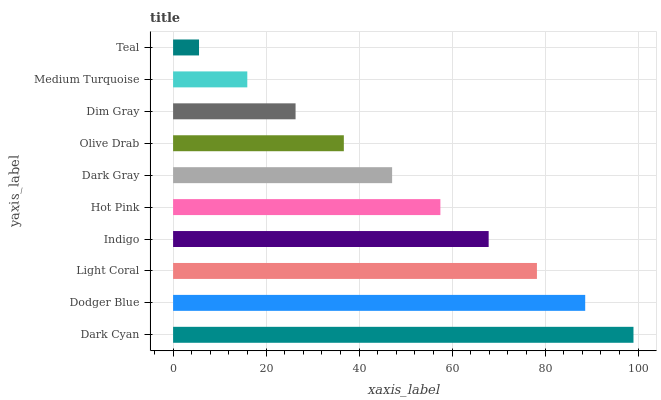Is Teal the minimum?
Answer yes or no. Yes. Is Dark Cyan the maximum?
Answer yes or no. Yes. Is Dodger Blue the minimum?
Answer yes or no. No. Is Dodger Blue the maximum?
Answer yes or no. No. Is Dark Cyan greater than Dodger Blue?
Answer yes or no. Yes. Is Dodger Blue less than Dark Cyan?
Answer yes or no. Yes. Is Dodger Blue greater than Dark Cyan?
Answer yes or no. No. Is Dark Cyan less than Dodger Blue?
Answer yes or no. No. Is Hot Pink the high median?
Answer yes or no. Yes. Is Dark Gray the low median?
Answer yes or no. Yes. Is Dark Cyan the high median?
Answer yes or no. No. Is Dim Gray the low median?
Answer yes or no. No. 